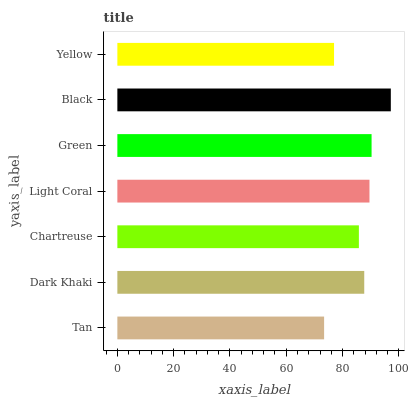Is Tan the minimum?
Answer yes or no. Yes. Is Black the maximum?
Answer yes or no. Yes. Is Dark Khaki the minimum?
Answer yes or no. No. Is Dark Khaki the maximum?
Answer yes or no. No. Is Dark Khaki greater than Tan?
Answer yes or no. Yes. Is Tan less than Dark Khaki?
Answer yes or no. Yes. Is Tan greater than Dark Khaki?
Answer yes or no. No. Is Dark Khaki less than Tan?
Answer yes or no. No. Is Dark Khaki the high median?
Answer yes or no. Yes. Is Dark Khaki the low median?
Answer yes or no. Yes. Is Green the high median?
Answer yes or no. No. Is Yellow the low median?
Answer yes or no. No. 